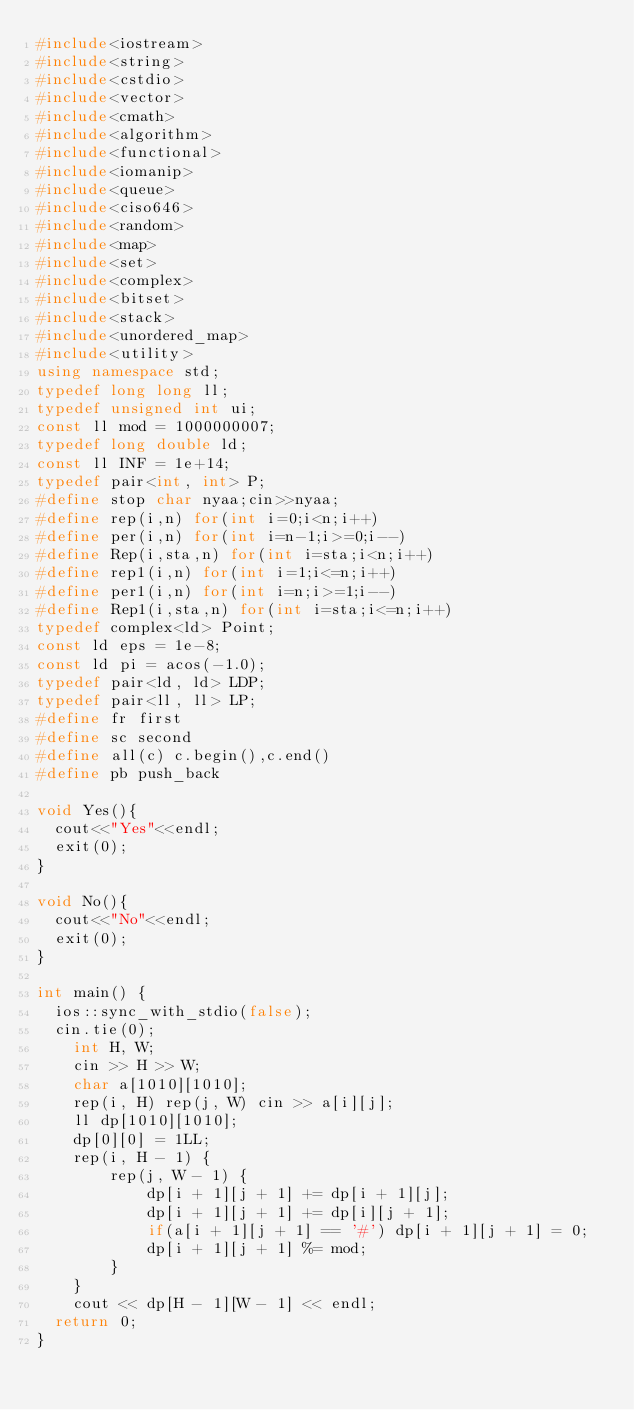<code> <loc_0><loc_0><loc_500><loc_500><_C++_>#include<iostream>
#include<string>
#include<cstdio>
#include<vector>
#include<cmath>
#include<algorithm>
#include<functional>
#include<iomanip>
#include<queue>
#include<ciso646>
#include<random>
#include<map>
#include<set>
#include<complex>
#include<bitset>
#include<stack>
#include<unordered_map>
#include<utility>
using namespace std;
typedef long long ll;
typedef unsigned int ui;
const ll mod = 1000000007;
typedef long double ld;
const ll INF = 1e+14;
typedef pair<int, int> P;
#define stop char nyaa;cin>>nyaa;
#define rep(i,n) for(int i=0;i<n;i++)
#define per(i,n) for(int i=n-1;i>=0;i--)
#define Rep(i,sta,n) for(int i=sta;i<n;i++)
#define rep1(i,n) for(int i=1;i<=n;i++)
#define per1(i,n) for(int i=n;i>=1;i--)
#define Rep1(i,sta,n) for(int i=sta;i<=n;i++)
typedef complex<ld> Point;
const ld eps = 1e-8;
const ld pi = acos(-1.0);
typedef pair<ld, ld> LDP;
typedef pair<ll, ll> LP;
#define fr first
#define sc second
#define all(c) c.begin(),c.end()
#define pb push_back

void Yes(){
	cout<<"Yes"<<endl;
	exit(0);
}
 
void No(){
	cout<<"No"<<endl;
	exit(0);
}

int main() {
	ios::sync_with_stdio(false);
	cin.tie(0);
    int H, W;
    cin >> H >> W;
    char a[1010][1010];
    rep(i, H) rep(j, W) cin >> a[i][j];
    ll dp[1010][1010];
    dp[0][0] = 1LL;
    rep(i, H - 1) {
        rep(j, W - 1) {
            dp[i + 1][j + 1] += dp[i + 1][j];
            dp[i + 1][j + 1] += dp[i][j + 1];
            if(a[i + 1][j + 1] == '#') dp[i + 1][j + 1] = 0;
            dp[i + 1][j + 1] %= mod;
        }
    }
    cout << dp[H - 1][W - 1] << endl;
	return 0;
}</code> 